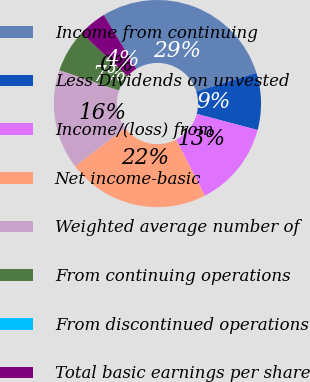<chart> <loc_0><loc_0><loc_500><loc_500><pie_chart><fcel>Income from continuing<fcel>Less Dividends on unvested<fcel>Income/(loss) from<fcel>Net income-basic<fcel>Weighted average number of<fcel>From continuing operations<fcel>From discontinued operations<fcel>Total basic earnings per share<nl><fcel>28.89%<fcel>8.89%<fcel>13.33%<fcel>22.22%<fcel>15.56%<fcel>6.67%<fcel>0.0%<fcel>4.44%<nl></chart> 